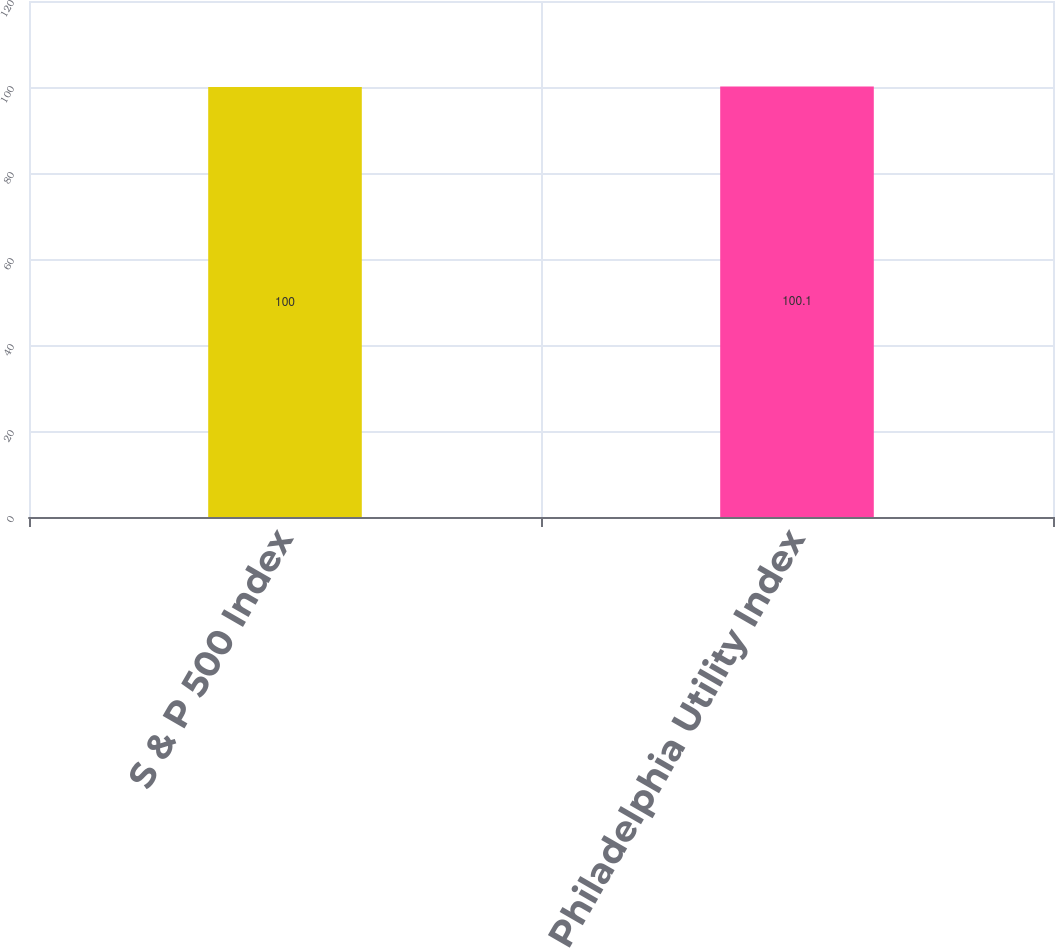Convert chart. <chart><loc_0><loc_0><loc_500><loc_500><bar_chart><fcel>S & P 500 Index<fcel>Philadelphia Utility Index<nl><fcel>100<fcel>100.1<nl></chart> 